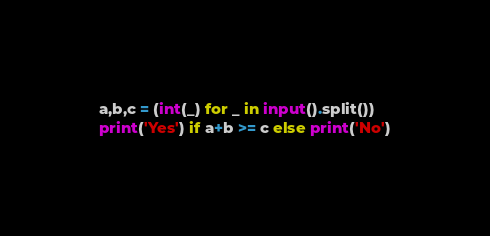Convert code to text. <code><loc_0><loc_0><loc_500><loc_500><_Python_>a,b,c = (int(_) for _ in input().split())
print('Yes') if a+b >= c else print('No')</code> 